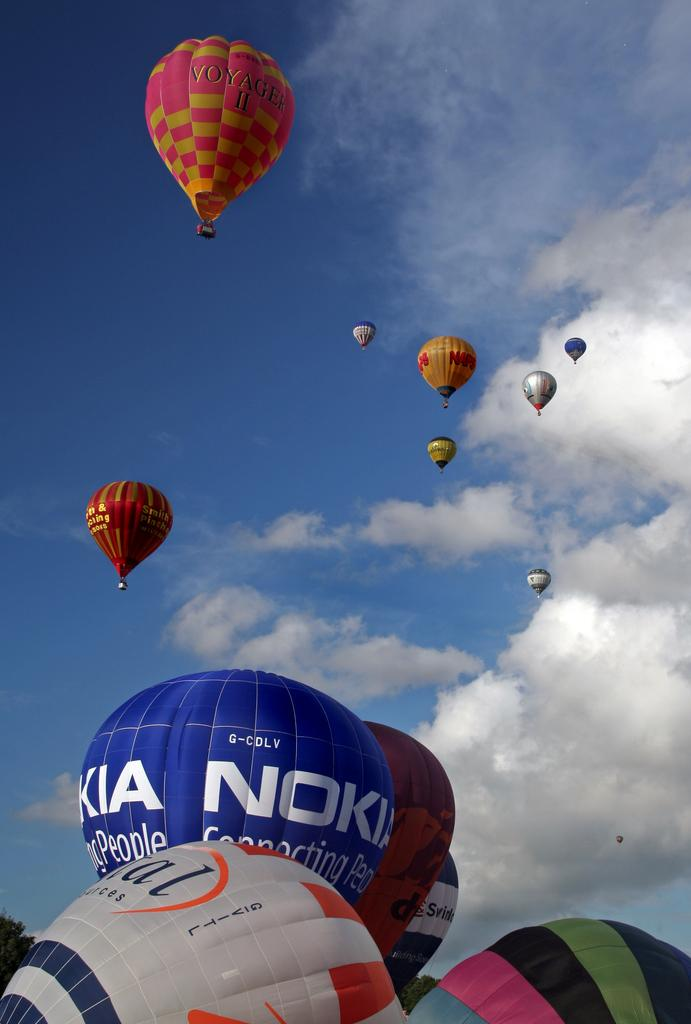<image>
Offer a succinct explanation of the picture presented. Colorful hot air balloons floating in the sky with a Nokia ad written on one of them. 